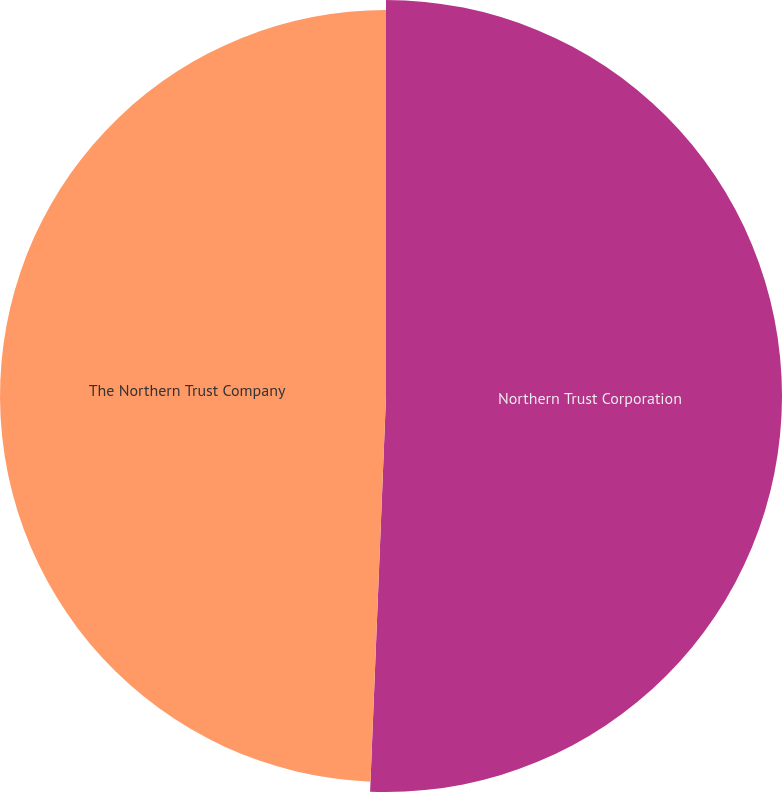Convert chart. <chart><loc_0><loc_0><loc_500><loc_500><pie_chart><fcel>Northern Trust Corporation<fcel>The Northern Trust Company<nl><fcel>50.64%<fcel>49.36%<nl></chart> 